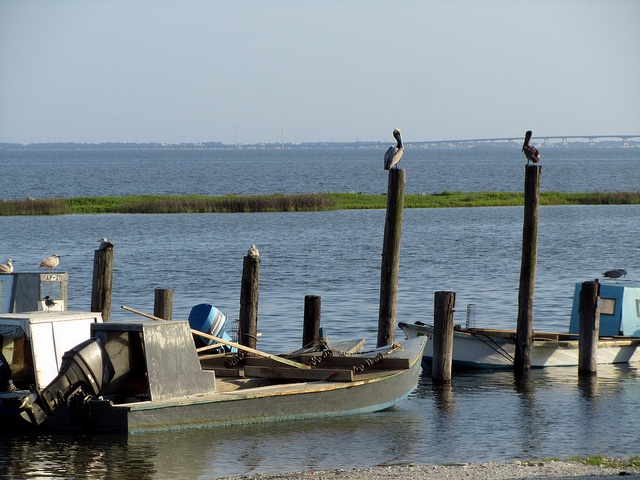Describe the objects in this image and their specific colors. I can see boat in darkgray, black, and gray tones, boat in darkgray, white, black, and gray tones, boat in darkgray, black, gray, and blue tones, bird in darkgray, black, and gray tones, and bird in darkgray, black, and gray tones in this image. 